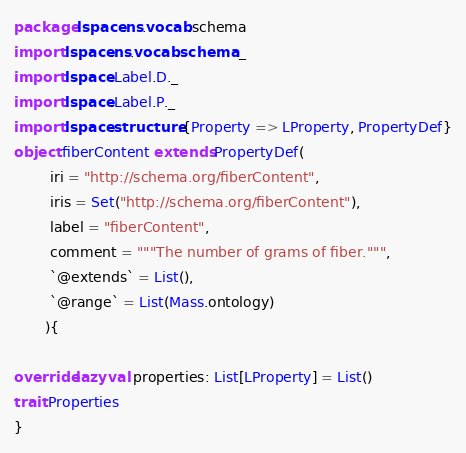Convert code to text. <code><loc_0><loc_0><loc_500><loc_500><_Scala_>package lspace.ns.vocab.schema
import lspace.ns.vocab.schema._
import lspace.Label.D._
import lspace.Label.P._
import lspace.structure.{Property => LProperty, PropertyDef}
object fiberContent extends PropertyDef(
        iri = "http://schema.org/fiberContent",
        iris = Set("http://schema.org/fiberContent"),
        label = "fiberContent",
        comment = """The number of grams of fiber.""",
        `@extends` = List(),
        `@range` = List(Mass.ontology)
       ){

override lazy val properties: List[LProperty] = List()
trait Properties 
}</code> 